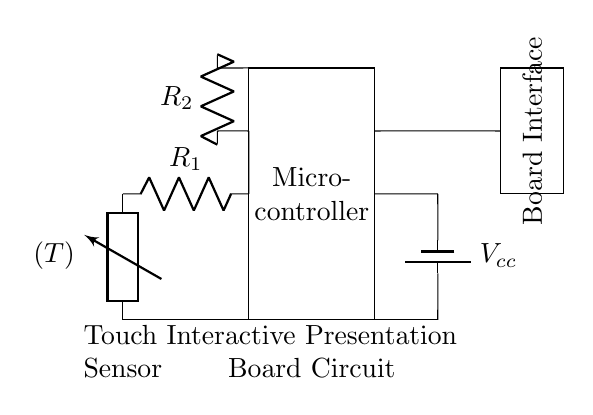What is the main controller in this circuit? The main controller is the microcontroller, which is represented as a rectangle in the diagram. It processes signals from the touch sensor and controls the output to the presentation board.
Answer: microcontroller What component converts touch interactions into electrical signals? The component that converts touch interactions into electrical signals is the touch sensor, depicted at the left of the circuit diagram.
Answer: touch sensor What is the role of resistor R1 in the circuit? Resistor R1 is likely used to limit the current flowing into the microcontroller from the touch sensor, protecting it from excessive current. Resistors are often used for this purpose in circuits.
Answer: current limitation How many resistors are present in this circuit? There are two resistors typed as R1 and R2 in the circuit diagram, each serving a specific function for current control in the circuit.
Answer: two What is the voltage supply in this circuit? The voltage supply is labeled as Vcc, which indicates a positive voltage source that powers the circuit. In many circuits, I would assume a common voltage like 5V, though it is not specifically labeled here.
Answer: Vcc What is the purpose of the board interface in this circuit? The board interface is used to connect the output from the microcontroller to the interactive presentation board, allowing signals to be sent to display or respond to interactions. It acts as the output stage of the circuit.
Answer: output connection What happens if R2 has a very high resistance value? If R2 has a very high resistance value, it may reduce the current flowing to the presentation board significantly, which could lead to insufficient power for the board to function correctly or respond to touch inputs.
Answer: reduced current 